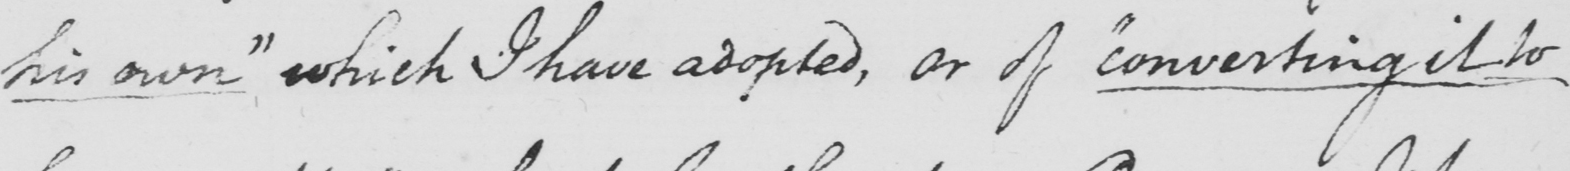What is written in this line of handwriting? his own "  which I have adopted , or of  " converting it to 